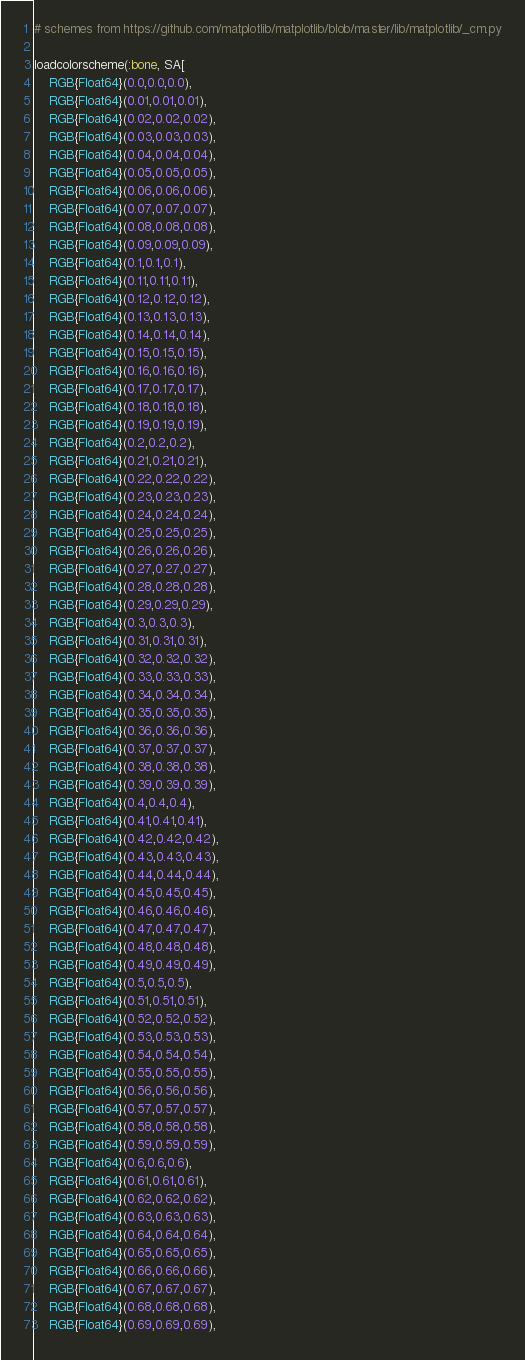<code> <loc_0><loc_0><loc_500><loc_500><_Julia_># schemes from https://github.com/matplotlib/matplotlib/blob/master/lib/matplotlib/_cm.py

loadcolorscheme(:bone, SA[
	RGB{Float64}(0.0,0.0,0.0),
	RGB{Float64}(0.01,0.01,0.01),
	RGB{Float64}(0.02,0.02,0.02),
	RGB{Float64}(0.03,0.03,0.03),
	RGB{Float64}(0.04,0.04,0.04),
	RGB{Float64}(0.05,0.05,0.05),
	RGB{Float64}(0.06,0.06,0.06),
	RGB{Float64}(0.07,0.07,0.07),
	RGB{Float64}(0.08,0.08,0.08),
	RGB{Float64}(0.09,0.09,0.09),
	RGB{Float64}(0.1,0.1,0.1),
	RGB{Float64}(0.11,0.11,0.11),
	RGB{Float64}(0.12,0.12,0.12),
	RGB{Float64}(0.13,0.13,0.13),
	RGB{Float64}(0.14,0.14,0.14),
	RGB{Float64}(0.15,0.15,0.15),
	RGB{Float64}(0.16,0.16,0.16),
	RGB{Float64}(0.17,0.17,0.17),
	RGB{Float64}(0.18,0.18,0.18),
	RGB{Float64}(0.19,0.19,0.19),
	RGB{Float64}(0.2,0.2,0.2),
	RGB{Float64}(0.21,0.21,0.21),
	RGB{Float64}(0.22,0.22,0.22),
	RGB{Float64}(0.23,0.23,0.23),
	RGB{Float64}(0.24,0.24,0.24),
	RGB{Float64}(0.25,0.25,0.25),
	RGB{Float64}(0.26,0.26,0.26),
	RGB{Float64}(0.27,0.27,0.27),
	RGB{Float64}(0.28,0.28,0.28),
	RGB{Float64}(0.29,0.29,0.29),
	RGB{Float64}(0.3,0.3,0.3),
	RGB{Float64}(0.31,0.31,0.31),
	RGB{Float64}(0.32,0.32,0.32),
	RGB{Float64}(0.33,0.33,0.33),
	RGB{Float64}(0.34,0.34,0.34),
	RGB{Float64}(0.35,0.35,0.35),
	RGB{Float64}(0.36,0.36,0.36),
	RGB{Float64}(0.37,0.37,0.37),
	RGB{Float64}(0.38,0.38,0.38),
	RGB{Float64}(0.39,0.39,0.39),
	RGB{Float64}(0.4,0.4,0.4),
	RGB{Float64}(0.41,0.41,0.41),
	RGB{Float64}(0.42,0.42,0.42),
	RGB{Float64}(0.43,0.43,0.43),
	RGB{Float64}(0.44,0.44,0.44),
	RGB{Float64}(0.45,0.45,0.45),
	RGB{Float64}(0.46,0.46,0.46),
	RGB{Float64}(0.47,0.47,0.47),
	RGB{Float64}(0.48,0.48,0.48),
	RGB{Float64}(0.49,0.49,0.49),
	RGB{Float64}(0.5,0.5,0.5),
	RGB{Float64}(0.51,0.51,0.51),
	RGB{Float64}(0.52,0.52,0.52),
	RGB{Float64}(0.53,0.53,0.53),
	RGB{Float64}(0.54,0.54,0.54),
	RGB{Float64}(0.55,0.55,0.55),
	RGB{Float64}(0.56,0.56,0.56),
	RGB{Float64}(0.57,0.57,0.57),
	RGB{Float64}(0.58,0.58,0.58),
	RGB{Float64}(0.59,0.59,0.59),
	RGB{Float64}(0.6,0.6,0.6),
	RGB{Float64}(0.61,0.61,0.61),
	RGB{Float64}(0.62,0.62,0.62),
	RGB{Float64}(0.63,0.63,0.63),
	RGB{Float64}(0.64,0.64,0.64),
	RGB{Float64}(0.65,0.65,0.65),
	RGB{Float64}(0.66,0.66,0.66),
	RGB{Float64}(0.67,0.67,0.67),
	RGB{Float64}(0.68,0.68,0.68),
	RGB{Float64}(0.69,0.69,0.69),</code> 